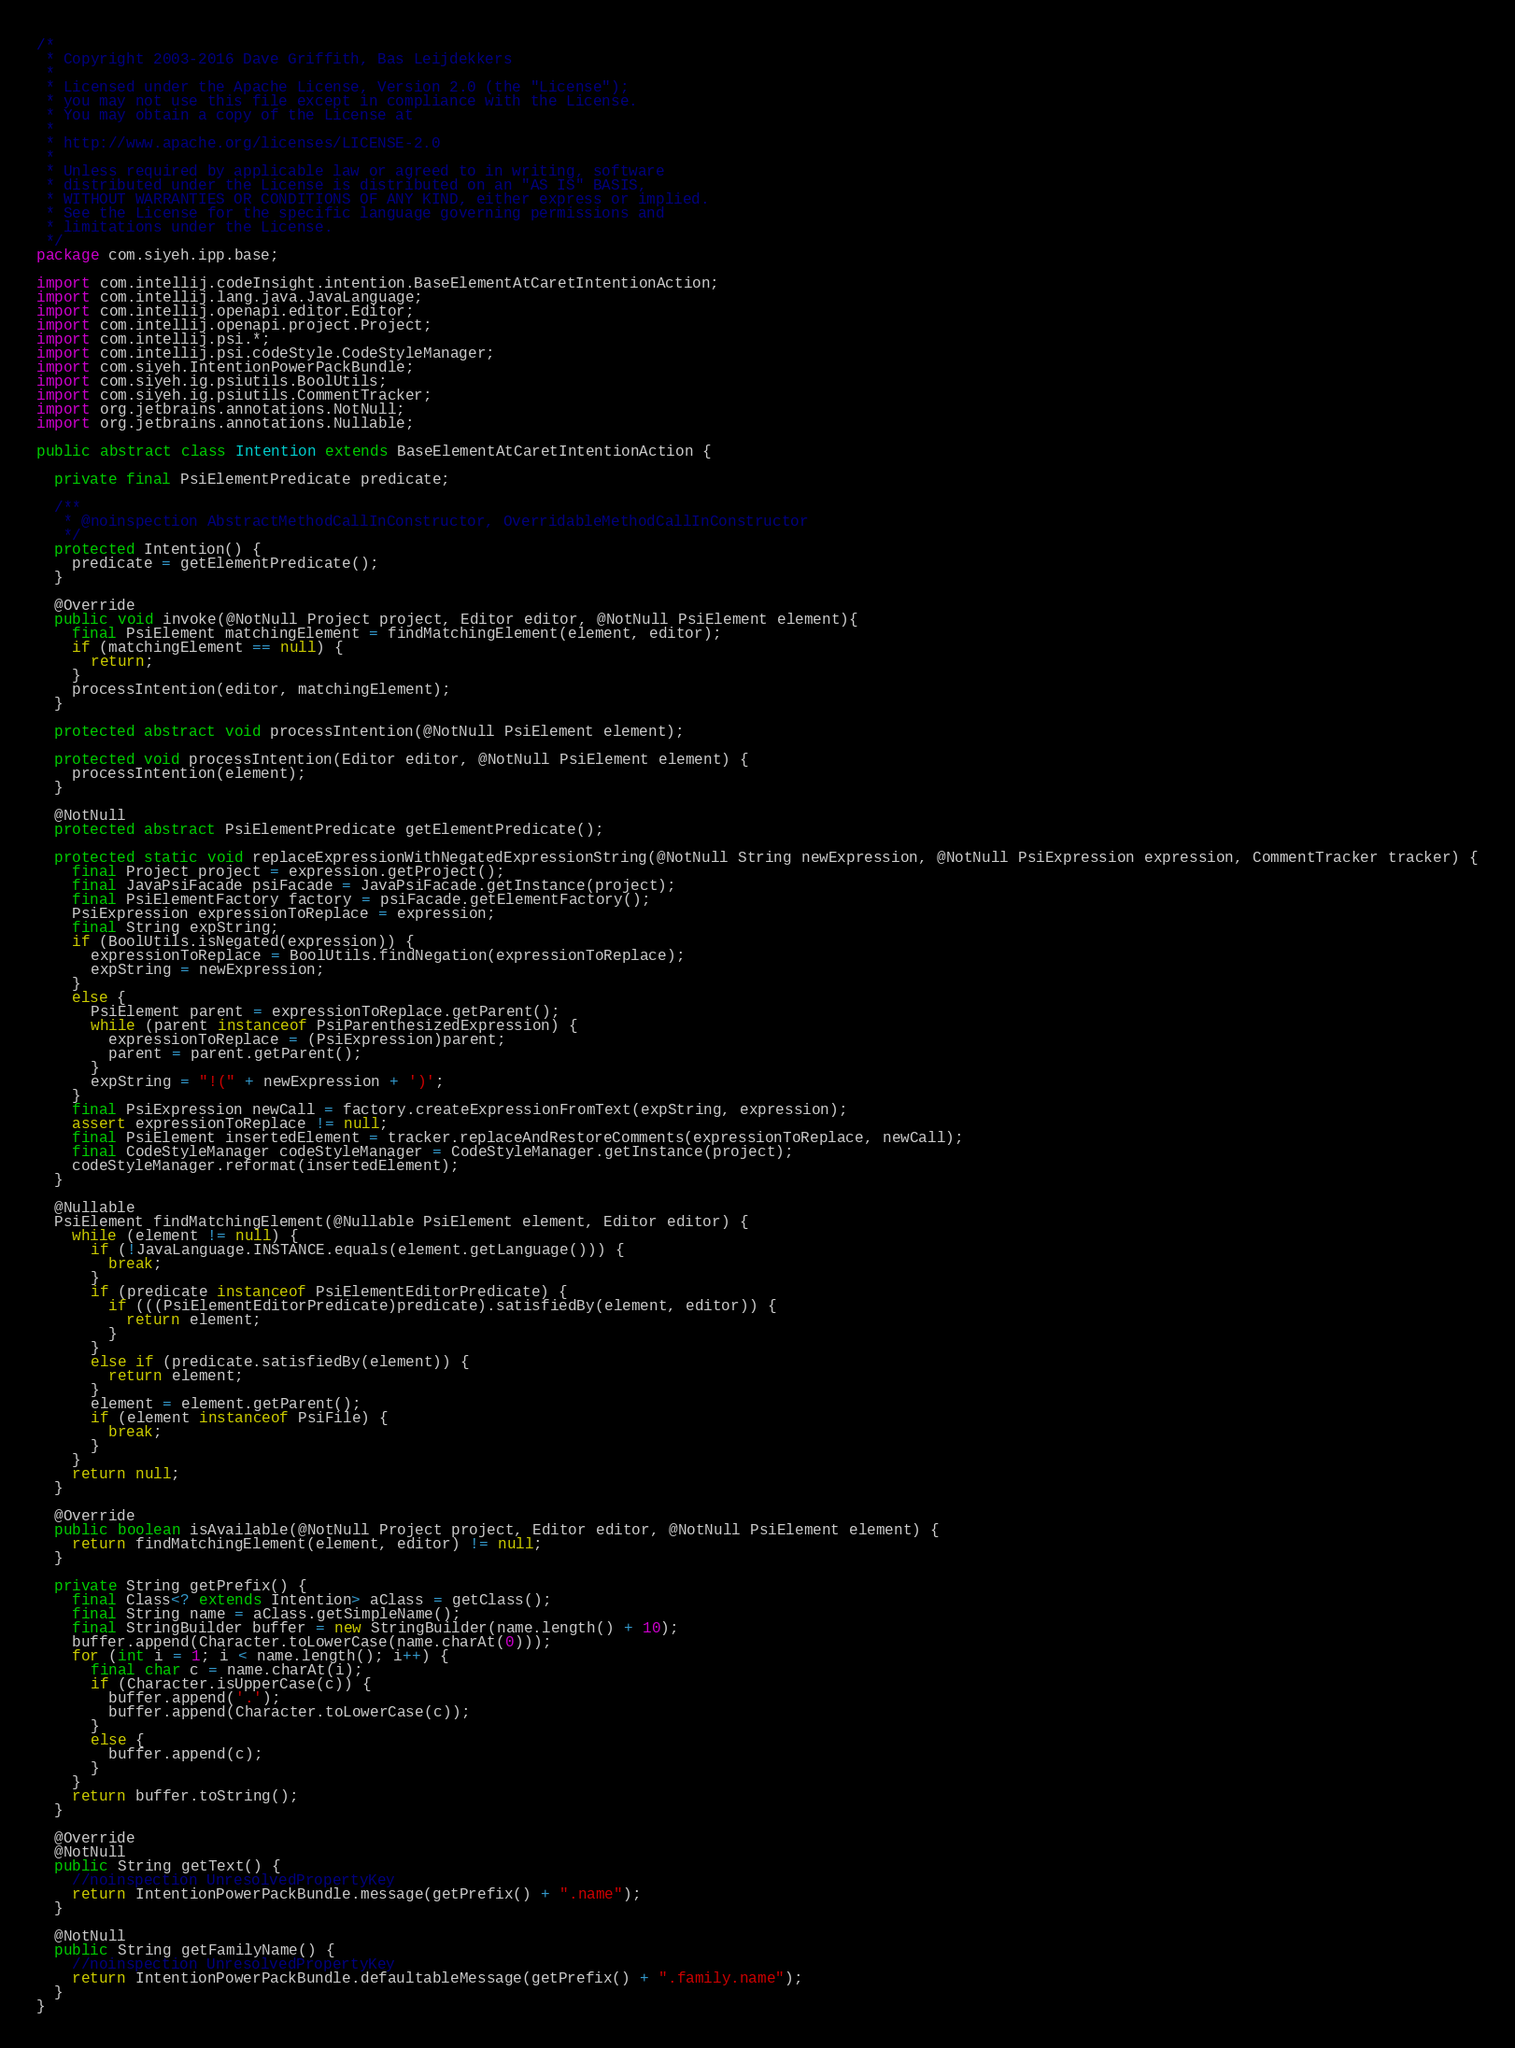<code> <loc_0><loc_0><loc_500><loc_500><_Java_>/*
 * Copyright 2003-2016 Dave Griffith, Bas Leijdekkers
 *
 * Licensed under the Apache License, Version 2.0 (the "License");
 * you may not use this file except in compliance with the License.
 * You may obtain a copy of the License at
 *
 * http://www.apache.org/licenses/LICENSE-2.0
 *
 * Unless required by applicable law or agreed to in writing, software
 * distributed under the License is distributed on an "AS IS" BASIS,
 * WITHOUT WARRANTIES OR CONDITIONS OF ANY KIND, either express or implied.
 * See the License for the specific language governing permissions and
 * limitations under the License.
 */
package com.siyeh.ipp.base;

import com.intellij.codeInsight.intention.BaseElementAtCaretIntentionAction;
import com.intellij.lang.java.JavaLanguage;
import com.intellij.openapi.editor.Editor;
import com.intellij.openapi.project.Project;
import com.intellij.psi.*;
import com.intellij.psi.codeStyle.CodeStyleManager;
import com.siyeh.IntentionPowerPackBundle;
import com.siyeh.ig.psiutils.BoolUtils;
import com.siyeh.ig.psiutils.CommentTracker;
import org.jetbrains.annotations.NotNull;
import org.jetbrains.annotations.Nullable;

public abstract class Intention extends BaseElementAtCaretIntentionAction {

  private final PsiElementPredicate predicate;

  /**
   * @noinspection AbstractMethodCallInConstructor, OverridableMethodCallInConstructor
   */
  protected Intention() {
    predicate = getElementPredicate();
  }

  @Override
  public void invoke(@NotNull Project project, Editor editor, @NotNull PsiElement element){
    final PsiElement matchingElement = findMatchingElement(element, editor);
    if (matchingElement == null) {
      return;
    }
    processIntention(editor, matchingElement);
  }

  protected abstract void processIntention(@NotNull PsiElement element);
  
  protected void processIntention(Editor editor, @NotNull PsiElement element) {
    processIntention(element);
  }

  @NotNull
  protected abstract PsiElementPredicate getElementPredicate();

  protected static void replaceExpressionWithNegatedExpressionString(@NotNull String newExpression, @NotNull PsiExpression expression, CommentTracker tracker) {
    final Project project = expression.getProject();
    final JavaPsiFacade psiFacade = JavaPsiFacade.getInstance(project);
    final PsiElementFactory factory = psiFacade.getElementFactory();
    PsiExpression expressionToReplace = expression;
    final String expString;
    if (BoolUtils.isNegated(expression)) {
      expressionToReplace = BoolUtils.findNegation(expressionToReplace);
      expString = newExpression;
    }
    else {
      PsiElement parent = expressionToReplace.getParent();
      while (parent instanceof PsiParenthesizedExpression) {
        expressionToReplace = (PsiExpression)parent;
        parent = parent.getParent();
      }
      expString = "!(" + newExpression + ')';
    }
    final PsiExpression newCall = factory.createExpressionFromText(expString, expression);
    assert expressionToReplace != null;
    final PsiElement insertedElement = tracker.replaceAndRestoreComments(expressionToReplace, newCall);
    final CodeStyleManager codeStyleManager = CodeStyleManager.getInstance(project);
    codeStyleManager.reformat(insertedElement);
  }

  @Nullable
  PsiElement findMatchingElement(@Nullable PsiElement element, Editor editor) {
    while (element != null) {
      if (!JavaLanguage.INSTANCE.equals(element.getLanguage())) {
        break;
      }
      if (predicate instanceof PsiElementEditorPredicate) {
        if (((PsiElementEditorPredicate)predicate).satisfiedBy(element, editor)) {
          return element;
        }
      }
      else if (predicate.satisfiedBy(element)) {
        return element;
      }
      element = element.getParent();
      if (element instanceof PsiFile) {
        break;
      }
    }
    return null;
  }

  @Override
  public boolean isAvailable(@NotNull Project project, Editor editor, @NotNull PsiElement element) {
    return findMatchingElement(element, editor) != null;
  }

  private String getPrefix() {
    final Class<? extends Intention> aClass = getClass();
    final String name = aClass.getSimpleName();
    final StringBuilder buffer = new StringBuilder(name.length() + 10);
    buffer.append(Character.toLowerCase(name.charAt(0)));
    for (int i = 1; i < name.length(); i++) {
      final char c = name.charAt(i);
      if (Character.isUpperCase(c)) {
        buffer.append('.');
        buffer.append(Character.toLowerCase(c));
      }
      else {
        buffer.append(c);
      }
    }
    return buffer.toString();
  }

  @Override
  @NotNull
  public String getText() {
    //noinspection UnresolvedPropertyKey
    return IntentionPowerPackBundle.message(getPrefix() + ".name");
  }

  @NotNull
  public String getFamilyName() {
    //noinspection UnresolvedPropertyKey
    return IntentionPowerPackBundle.defaultableMessage(getPrefix() + ".family.name");
  }
}</code> 